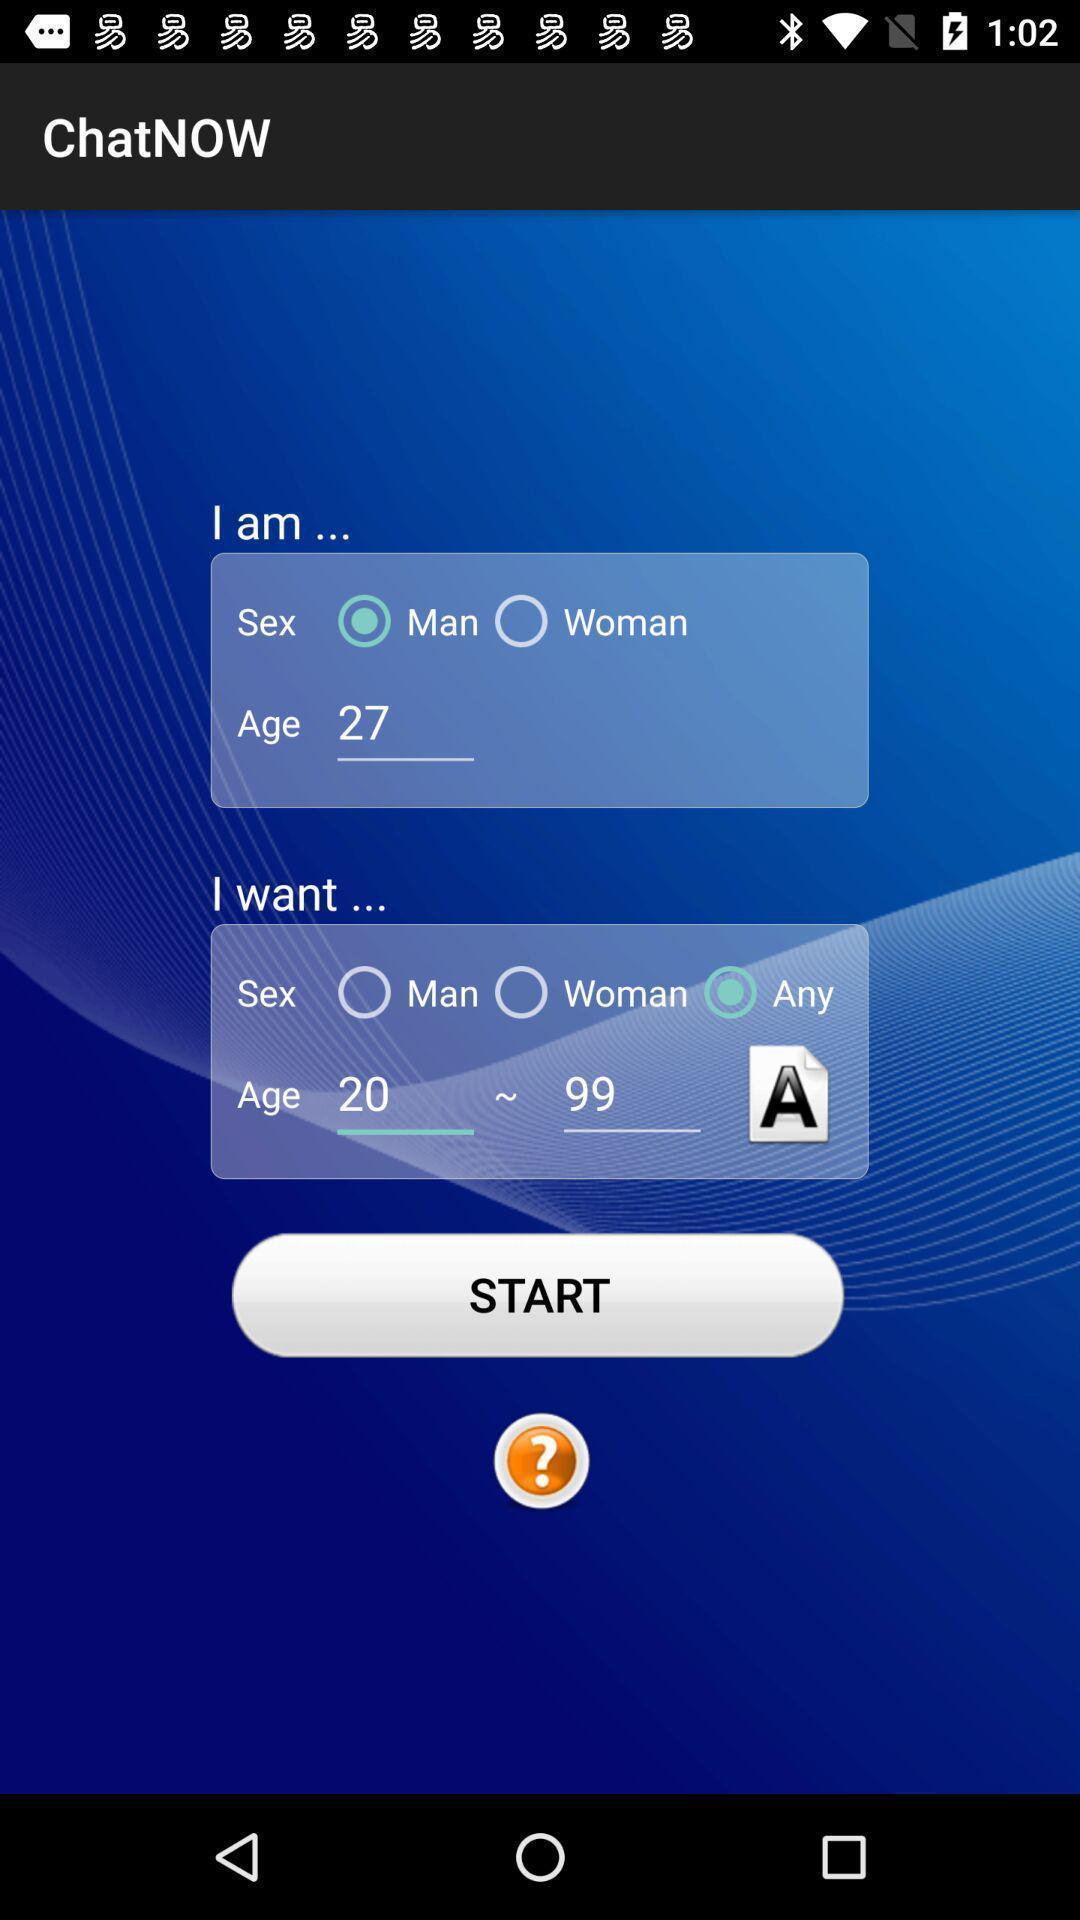Provide a textual representation of this image. Page showing start option. 